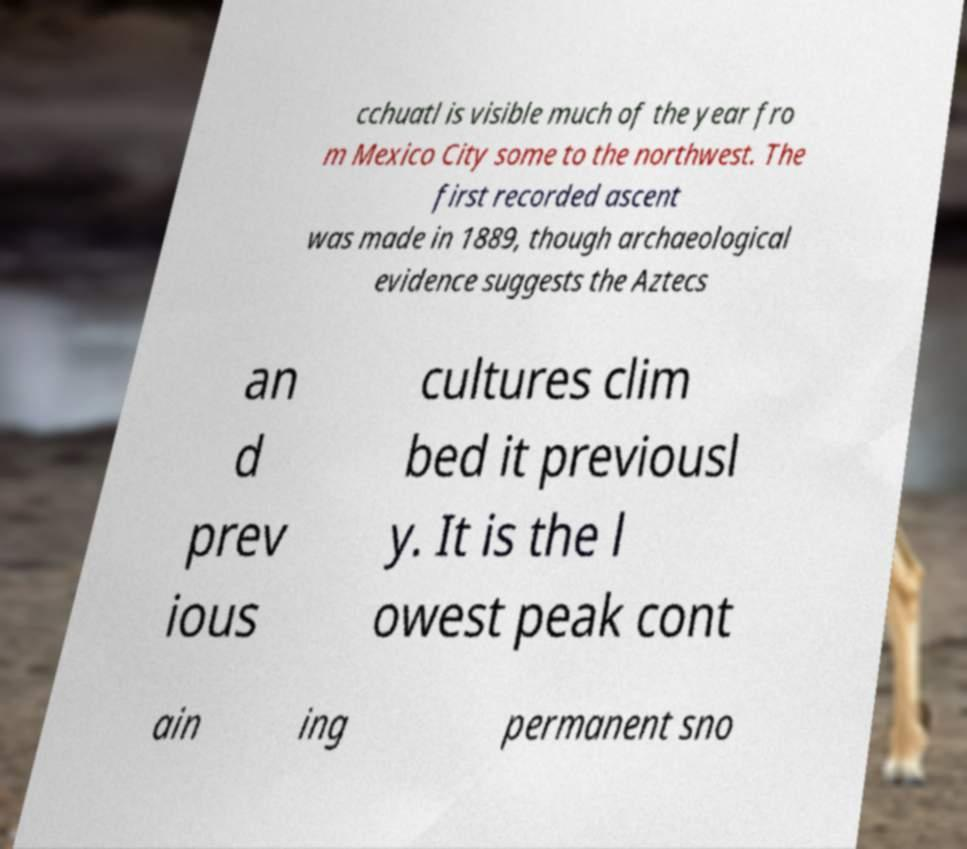What messages or text are displayed in this image? I need them in a readable, typed format. cchuatl is visible much of the year fro m Mexico City some to the northwest. The first recorded ascent was made in 1889, though archaeological evidence suggests the Aztecs an d prev ious cultures clim bed it previousl y. It is the l owest peak cont ain ing permanent sno 